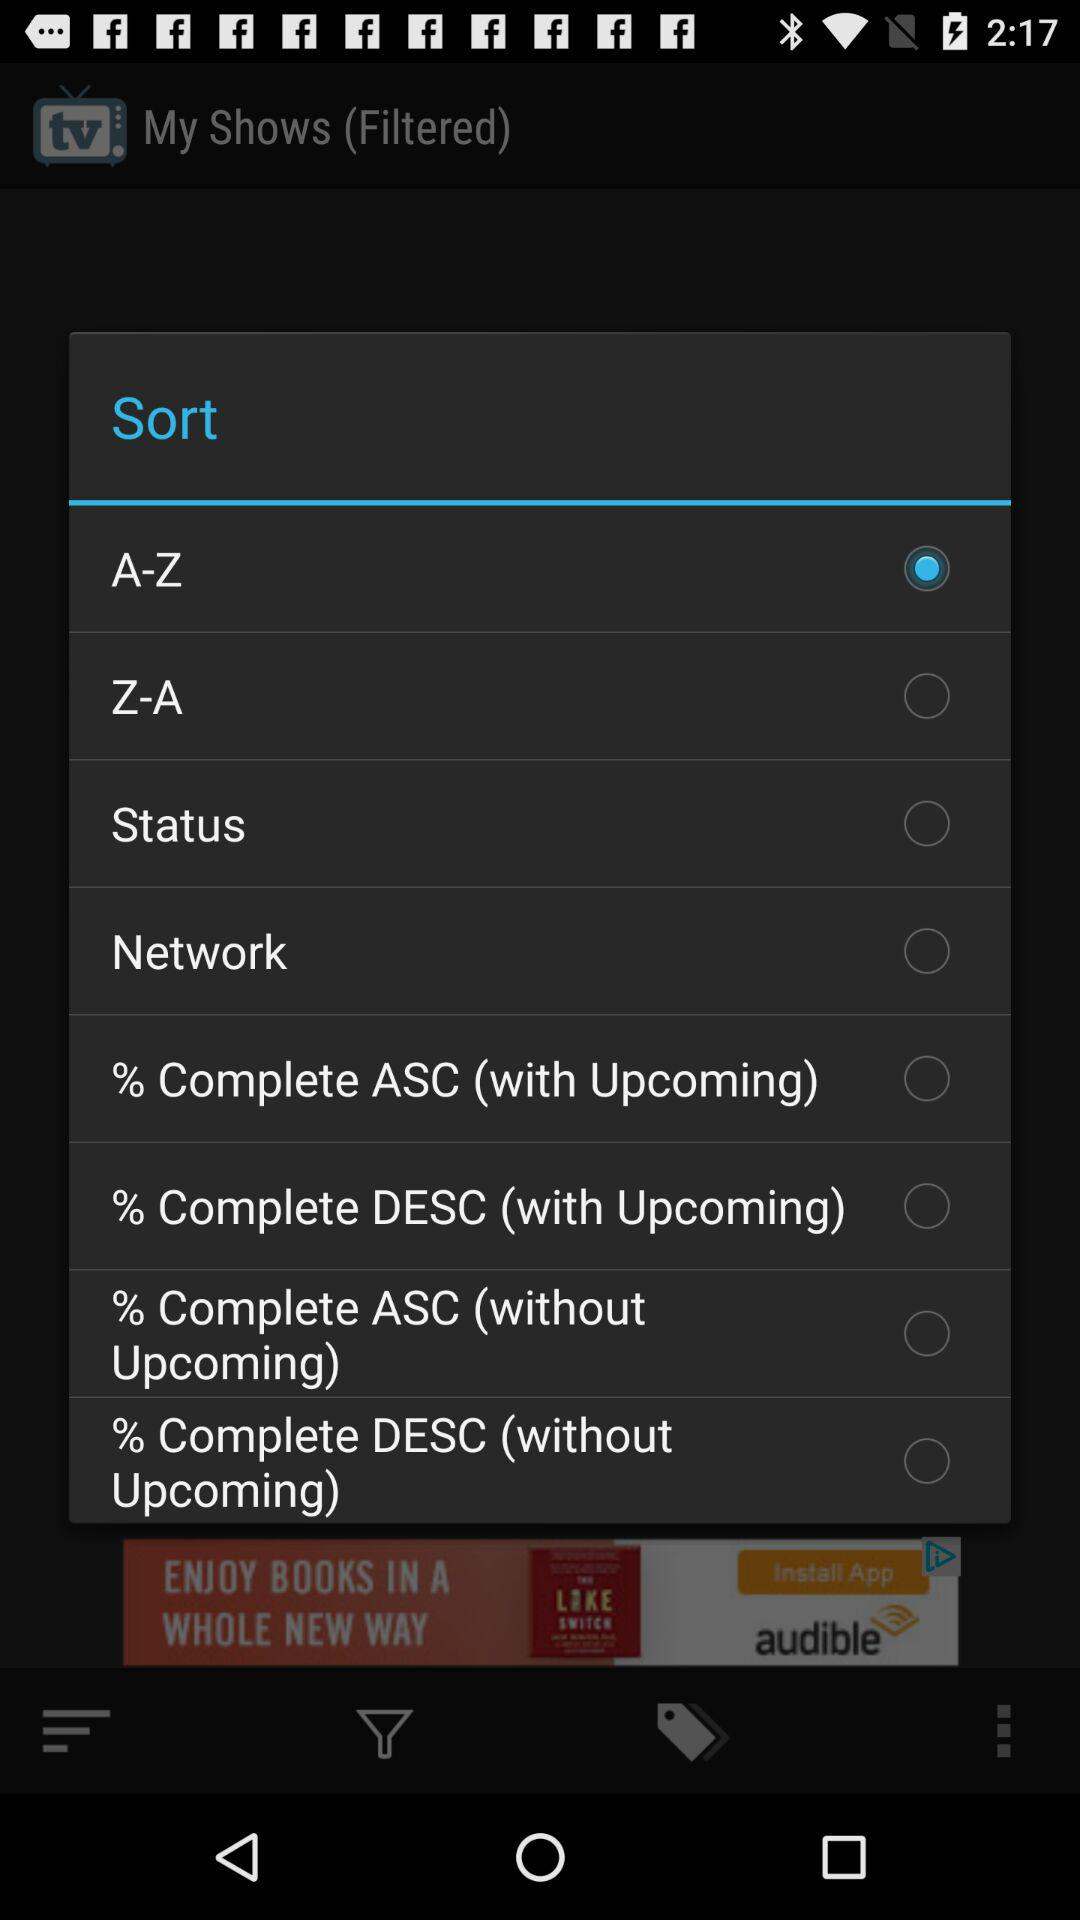How many sort options are available?
Answer the question using a single word or phrase. 8 